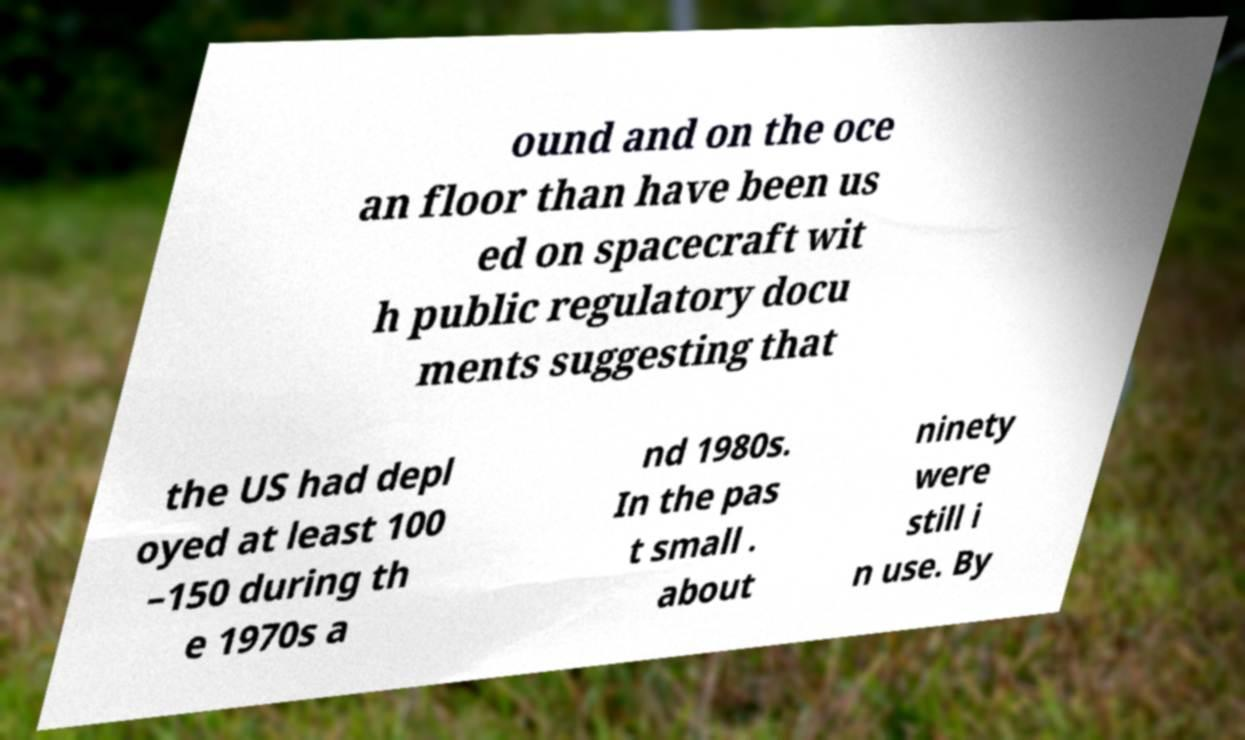Could you assist in decoding the text presented in this image and type it out clearly? ound and on the oce an floor than have been us ed on spacecraft wit h public regulatory docu ments suggesting that the US had depl oyed at least 100 –150 during th e 1970s a nd 1980s. In the pas t small . about ninety were still i n use. By 